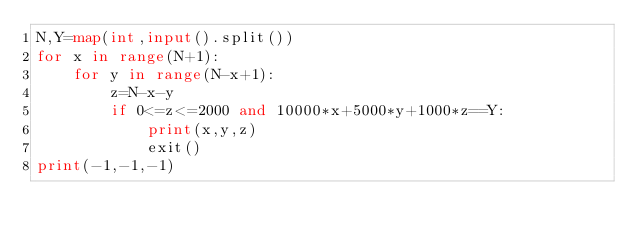Convert code to text. <code><loc_0><loc_0><loc_500><loc_500><_Python_>N,Y=map(int,input().split())
for x in range(N+1):
    for y in range(N-x+1):
        z=N-x-y
        if 0<=z<=2000 and 10000*x+5000*y+1000*z==Y:
            print(x,y,z)
            exit()
print(-1,-1,-1)</code> 